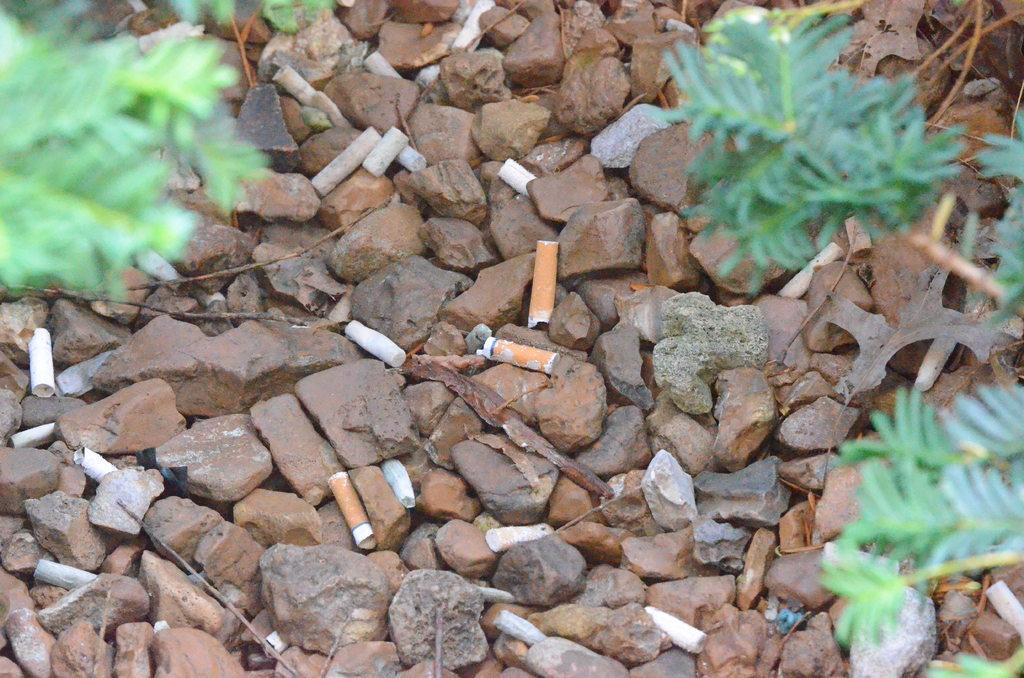What type of objects can be seen in the image? There are stones and plants in the image. Are there any man-made objects present in the image? Yes, there are cigarette filters in the image. What time of day is depicted in the image? The time of day is not visible or mentioned in the image, so it cannot be determined. Can you see a clam in the image? There is no clam present in the image. 